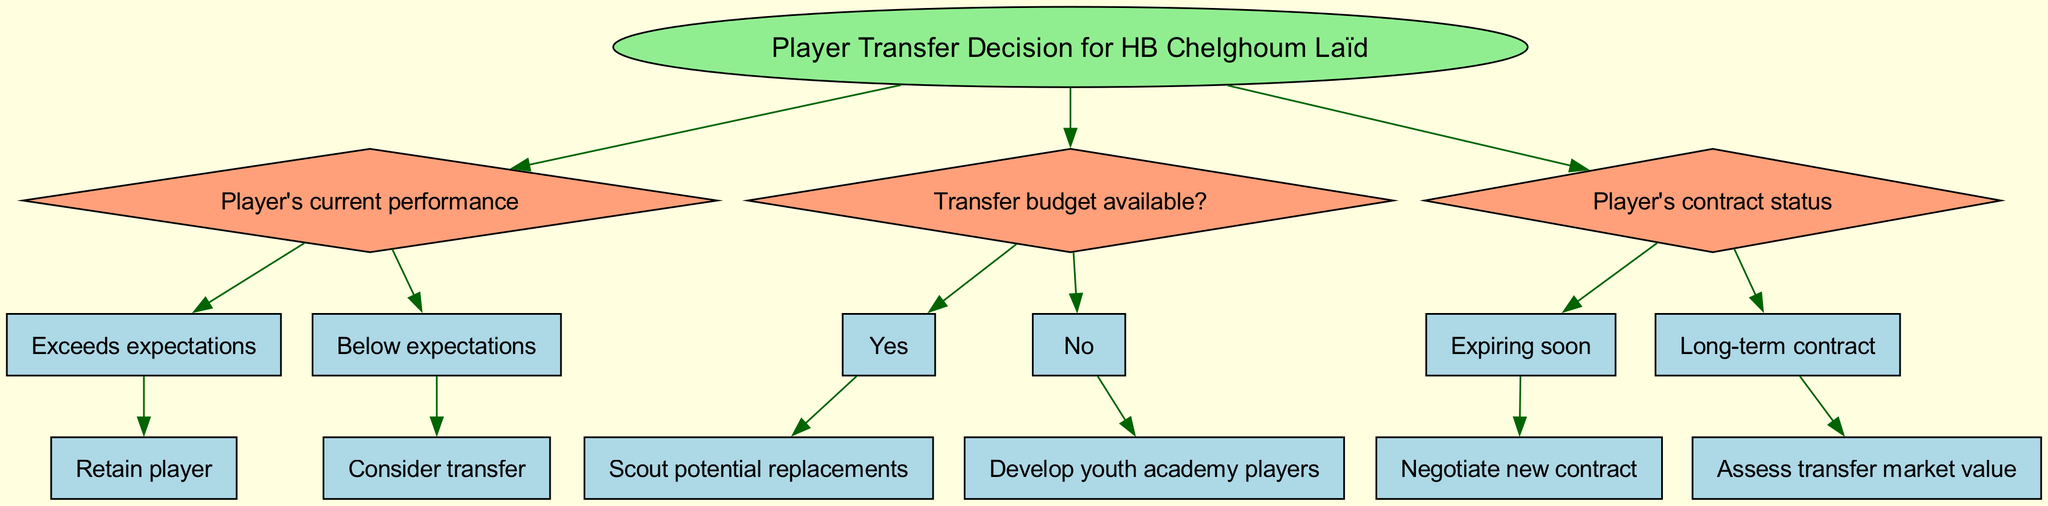What is the root of the decision tree? The root is the starting point of the decision process, which in this case is "Player Transfer Decision for HB Chelghoum Laïd". This is visually represented as the main node at the top of the diagram.
Answer: Player Transfer Decision for HB Chelghoum Laïd How many main nodes are present in the decision tree? The diagram shows three main decision nodes: "Player's current performance", "Transfer budget available?", and "Player's contract status". Counting these gives a total of three main nodes.
Answer: 3 If a player's performance is below expectations, what is the next step? According to the decision tree, if the player's performance is below expectations, the next step is to "Consider transfer". This conclusion follows the path from the "Player's current performance" node leading to the corresponding child node.
Answer: Consider transfer What action is recommended if there is no transfer budget available? If there is no transfer budget available according to the decision tree, the recommended action is to "Develop youth academy players". This is the outcome of the "Transfer budget available?" node when selecting the "No" option.
Answer: Develop youth academy players What should be done if a player's contract is expiring soon? If a player's contract is expiring soon, the decision tree indicates that the next step is to "Negotiate new contract". This follows from the "Player's contract status" decision node and selecting the "Expiring soon" child node.
Answer: Negotiate new contract What is the follow-up action if the transfer budget is available? If the transfer budget is available, the follow-up action according to the decision tree is to "Scout potential replacements". This follows the "Transfer budget available?" node's "Yes" pathway.
Answer: Scout potential replacements How many child nodes does the "Player's current performance" node have? The "Player's current performance" node has two child nodes: "Exceeds expectations" and "Below expectations". This indicates that there are two possible outcomes based on the player's performance level.
Answer: 2 What can be concluded if a player is retained after exceeding expectations? If a player exceeds expectations and is retained, it suggests a successful performance. This action is represented as the direct outcome from the "Exceeds expectations" child node, leading to the decision of retaining the player.
Answer: Retain player 